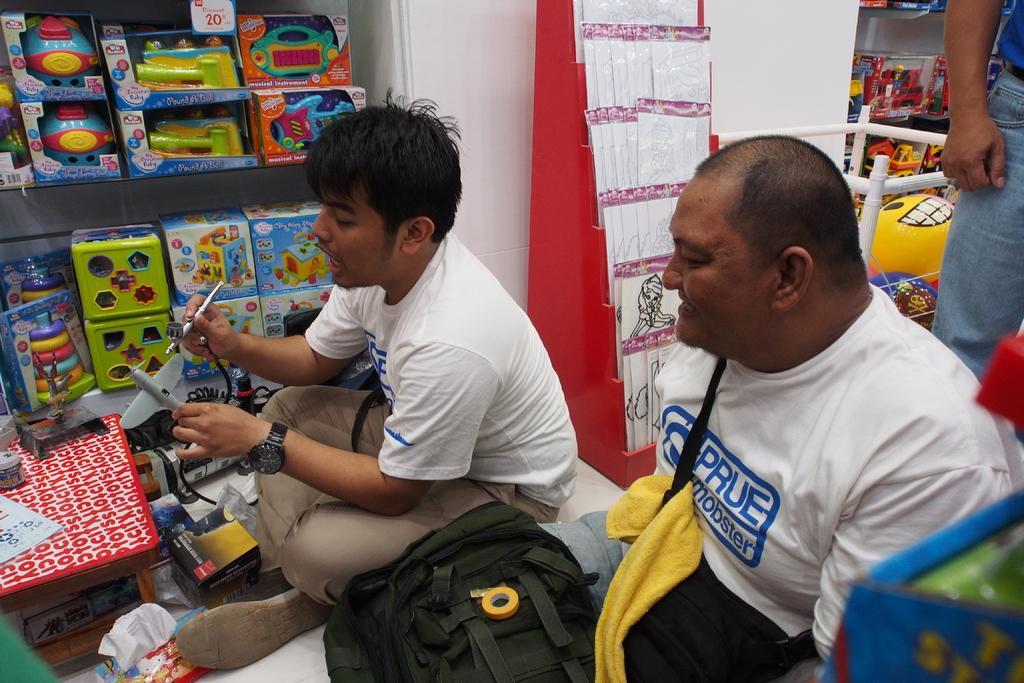Can you describe this image briefly? Here in this picture we can see two men sitting over a place and the person on the right side is smiling and in front of him we can see a bag present and the person on the left side is holding toy and speaking something about it and in front him we can see a table, on which we can see somethings present and beside him we can see racks with number of toys present in it and on the right side we can see another person standing and behind him we can see some balloons and some tattoos also present over there. 